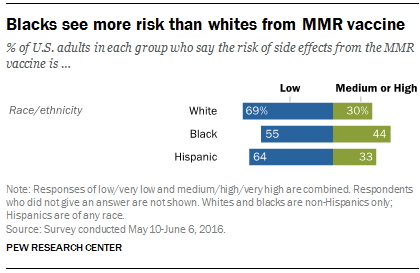Give some essential details in this illustration. The missing value is 69. The missing word is not provided. The missing value is 64. The missing number is 55. To calculate the final result, we would add all the green bars with a value below 40, multiply the result by the median blue bar, and then obtain the final answer. 